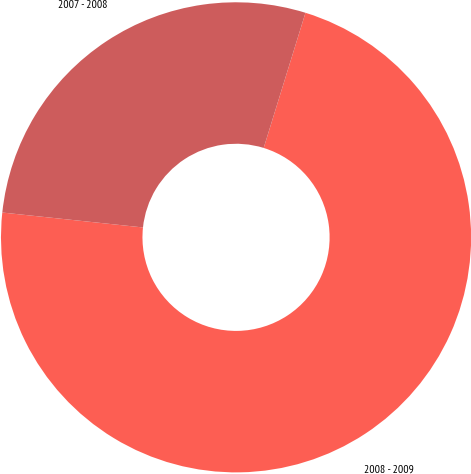Convert chart to OTSL. <chart><loc_0><loc_0><loc_500><loc_500><pie_chart><fcel>2008 - 2009<fcel>2007 - 2008<nl><fcel>71.91%<fcel>28.09%<nl></chart> 